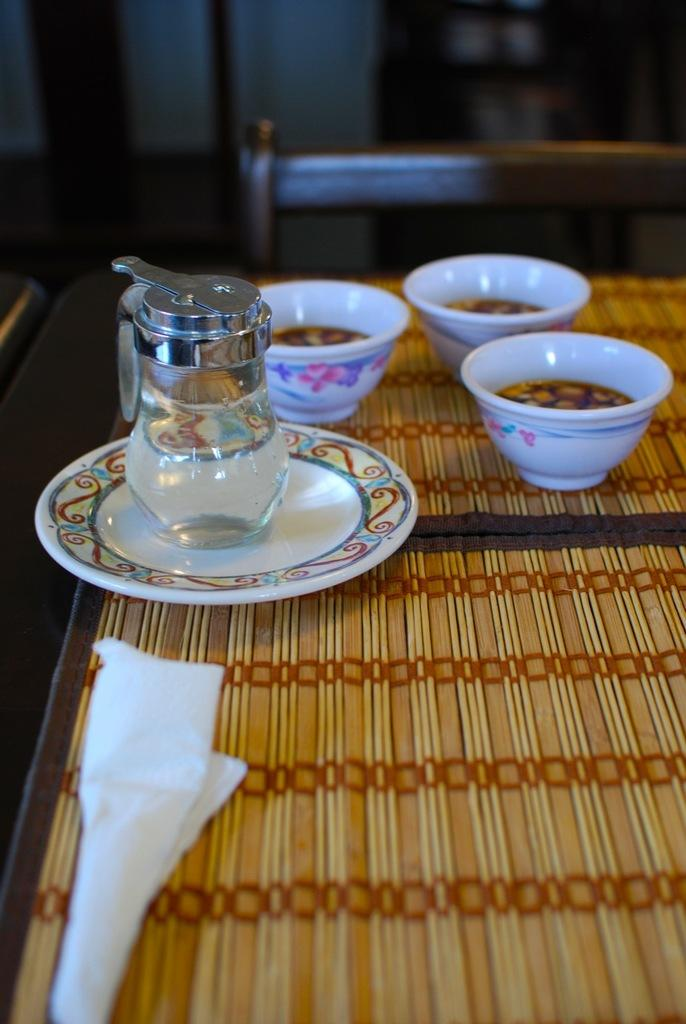What piece of furniture is present in the image? There is a table in the image. What objects are placed on the table? There are bowls, a plate, and a jar on the table. Is there any seating visible in the image? Yes, there is a chair in the image. What type of education is being provided by the throne in the image? There is no throne present in the image, so no education is being provided. What type of tank is visible in the image? There is no tank present in the image. 